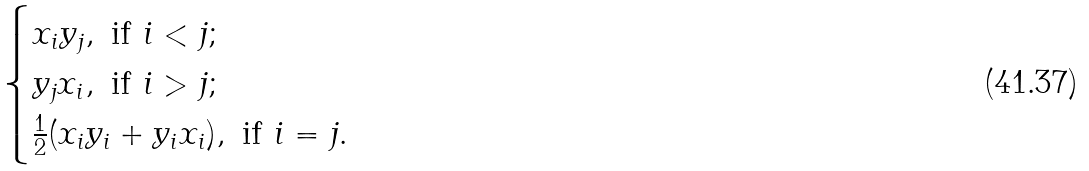Convert formula to latex. <formula><loc_0><loc_0><loc_500><loc_500>\begin{cases} x _ { i } y _ { j } , \text { if $i< j$;} \\ y _ { j } x _ { i } , \text { if $i> j$;} \\ \frac { 1 } { 2 } ( x _ { i } y _ { i } + y _ { i } x _ { i } ) , \text { if $i=j$.} \end{cases}</formula> 